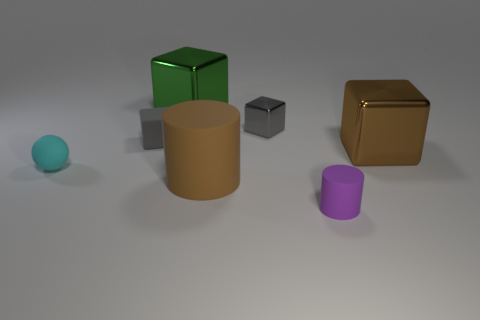Is there anything else that is the same shape as the big brown metallic thing?
Your answer should be compact. Yes. There is a small thing that is the same material as the big brown block; what is its color?
Offer a very short reply. Gray. How many objects are either brown objects or rubber blocks?
Give a very brief answer. 3. There is a green block; does it have the same size as the brown thing that is behind the brown rubber cylinder?
Make the answer very short. Yes. What is the color of the metal thing in front of the rubber thing behind the large cube to the right of the small purple matte cylinder?
Provide a succinct answer. Brown. The tiny sphere is what color?
Provide a short and direct response. Cyan. Are there more large objects that are to the left of the small matte cylinder than gray metallic things left of the matte cube?
Your answer should be compact. Yes. There is a large green thing; is its shape the same as the tiny object in front of the small cyan matte ball?
Offer a very short reply. No. There is a cylinder in front of the big brown cylinder; is it the same size as the rubber thing that is to the left of the tiny gray matte object?
Offer a very short reply. Yes. There is a big shiny object behind the metallic block that is on the right side of the small purple object; are there any brown metallic blocks on the left side of it?
Offer a very short reply. No. 